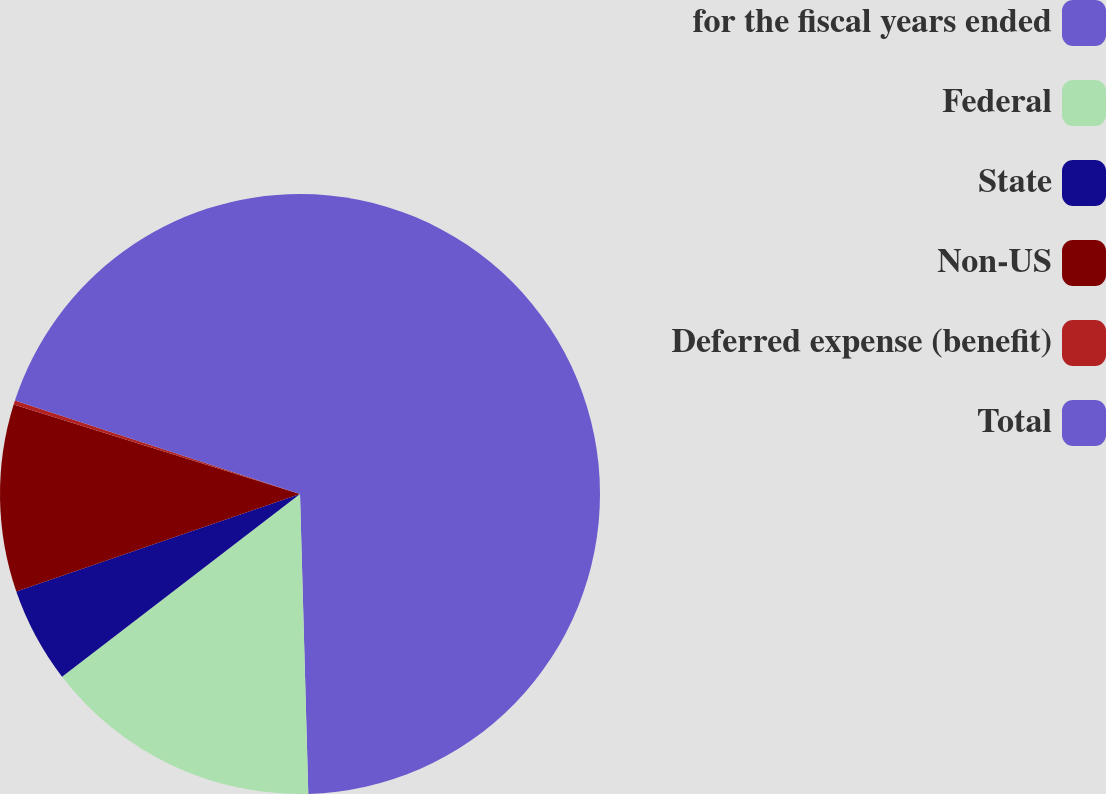Convert chart to OTSL. <chart><loc_0><loc_0><loc_500><loc_500><pie_chart><fcel>for the fiscal years ended<fcel>Federal<fcel>State<fcel>Non-US<fcel>Deferred expense (benefit)<fcel>Total<nl><fcel>49.56%<fcel>15.02%<fcel>5.15%<fcel>10.09%<fcel>0.22%<fcel>19.96%<nl></chart> 